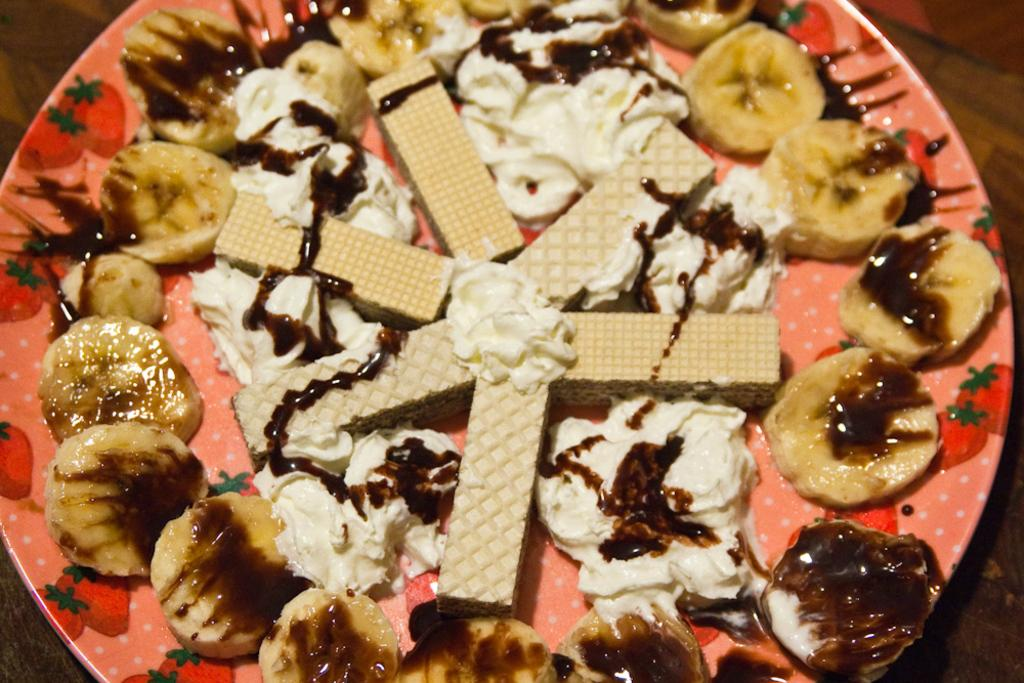What type of food items can be seen in the image? There are food items in the image, including banana slices. Can you describe any specific ingredients or toppings visible in the image? Cream is visible in the image. How are the food items arranged or presented in the image? The food items are on a plate. What type of crow is sitting on the governor's shoulder in the image? There is no crow or governor present in the image. How does the anger of the food items manifest in the image? The food items do not exhibit emotions like anger in the image. 